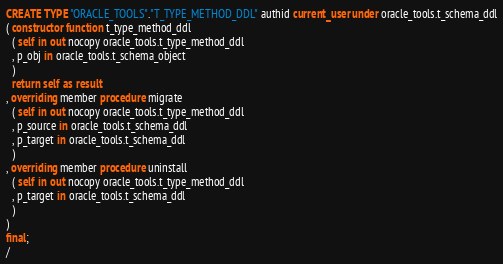<code> <loc_0><loc_0><loc_500><loc_500><_SQL_>CREATE TYPE "ORACLE_TOOLS"."T_TYPE_METHOD_DDL" authid current_user under oracle_tools.t_schema_ddl
( constructor function t_type_method_ddl
  ( self in out nocopy oracle_tools.t_type_method_ddl
  , p_obj in oracle_tools.t_schema_object
  )
  return self as result
, overriding member procedure migrate
  ( self in out nocopy oracle_tools.t_type_method_ddl
  , p_source in oracle_tools.t_schema_ddl
  , p_target in oracle_tools.t_schema_ddl
  )
, overriding member procedure uninstall
  ( self in out nocopy oracle_tools.t_type_method_ddl
  , p_target in oracle_tools.t_schema_ddl
  )
)
final;
/

</code> 